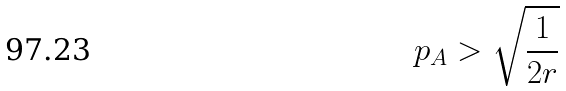Convert formula to latex. <formula><loc_0><loc_0><loc_500><loc_500>p _ { A } > \sqrt { \frac { 1 } { 2 r } }</formula> 